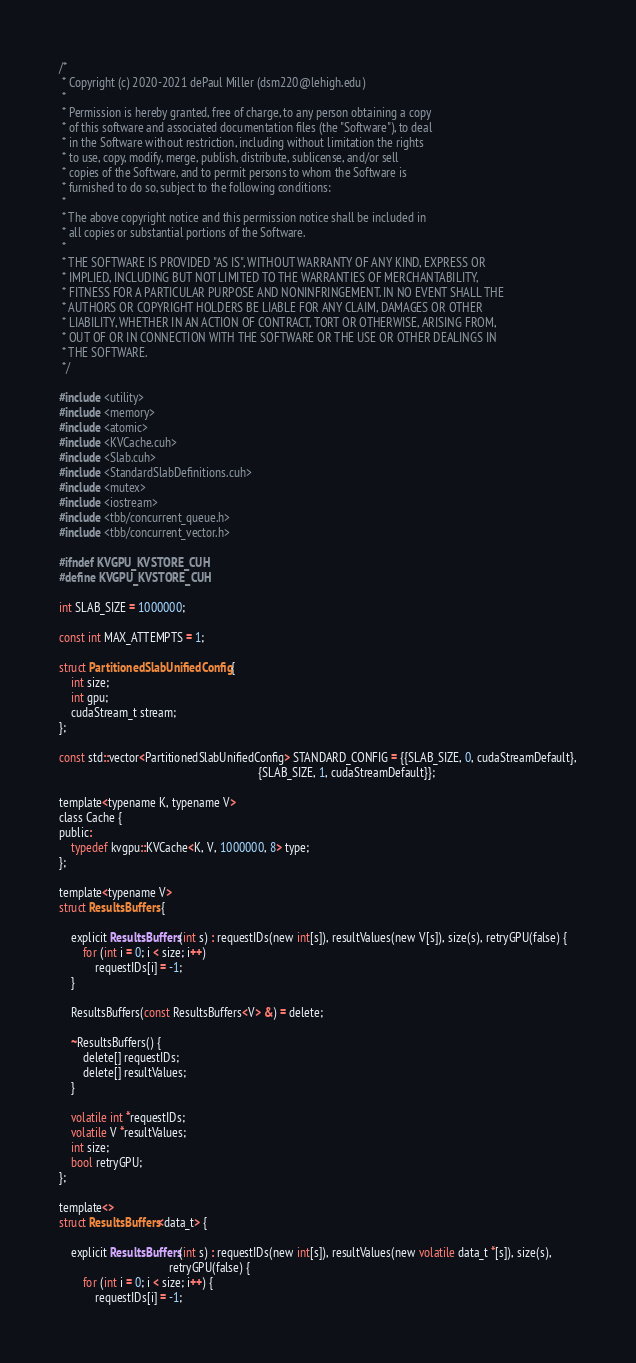<code> <loc_0><loc_0><loc_500><loc_500><_Cuda_>/*
 * Copyright (c) 2020-2021 dePaul Miller (dsm220@lehigh.edu)
 *
 * Permission is hereby granted, free of charge, to any person obtaining a copy
 * of this software and associated documentation files (the "Software"), to deal
 * in the Software without restriction, including without limitation the rights
 * to use, copy, modify, merge, publish, distribute, sublicense, and/or sell
 * copies of the Software, and to permit persons to whom the Software is
 * furnished to do so, subject to the following conditions:
 *
 * The above copyright notice and this permission notice shall be included in
 * all copies or substantial portions of the Software.
 *
 * THE SOFTWARE IS PROVIDED "AS IS", WITHOUT WARRANTY OF ANY KIND, EXPRESS OR
 * IMPLIED, INCLUDING BUT NOT LIMITED TO THE WARRANTIES OF MERCHANTABILITY,
 * FITNESS FOR A PARTICULAR PURPOSE AND NONINFRINGEMENT. IN NO EVENT SHALL THE
 * AUTHORS OR COPYRIGHT HOLDERS BE LIABLE FOR ANY CLAIM, DAMAGES OR OTHER
 * LIABILITY, WHETHER IN AN ACTION OF CONTRACT, TORT OR OTHERWISE, ARISING FROM,
 * OUT OF OR IN CONNECTION WITH THE SOFTWARE OR THE USE OR OTHER DEALINGS IN
 * THE SOFTWARE.
 */

#include <utility>
#include <memory>
#include <atomic>
#include <KVCache.cuh>
#include <Slab.cuh>
#include <StandardSlabDefinitions.cuh>
#include <mutex>
#include <iostream>
#include <tbb/concurrent_queue.h>
#include <tbb/concurrent_vector.h>

#ifndef KVGPU_KVSTORE_CUH
#define KVGPU_KVSTORE_CUH

int SLAB_SIZE = 1000000;

const int MAX_ATTEMPTS = 1;

struct PartitionedSlabUnifiedConfig {
    int size;
    int gpu;
    cudaStream_t stream;
};

const std::vector<PartitionedSlabUnifiedConfig> STANDARD_CONFIG = {{SLAB_SIZE, 0, cudaStreamDefault},
                                                                   {SLAB_SIZE, 1, cudaStreamDefault}};

template<typename K, typename V>
class Cache {
public:
    typedef kvgpu::KVCache<K, V, 1000000, 8> type;
};

template<typename V>
struct ResultsBuffers {

    explicit ResultsBuffers(int s) : requestIDs(new int[s]), resultValues(new V[s]), size(s), retryGPU(false) {
        for (int i = 0; i < size; i++)
            requestIDs[i] = -1;
    }

    ResultsBuffers(const ResultsBuffers<V> &) = delete;

    ~ResultsBuffers() {
        delete[] requestIDs;
        delete[] resultValues;
    }

    volatile int *requestIDs;
    volatile V *resultValues;
    int size;
    bool retryGPU;
};

template<>
struct ResultsBuffers<data_t> {

    explicit ResultsBuffers(int s) : requestIDs(new int[s]), resultValues(new volatile data_t *[s]), size(s),
                                     retryGPU(false) {
        for (int i = 0; i < size; i++) {
            requestIDs[i] = -1;</code> 